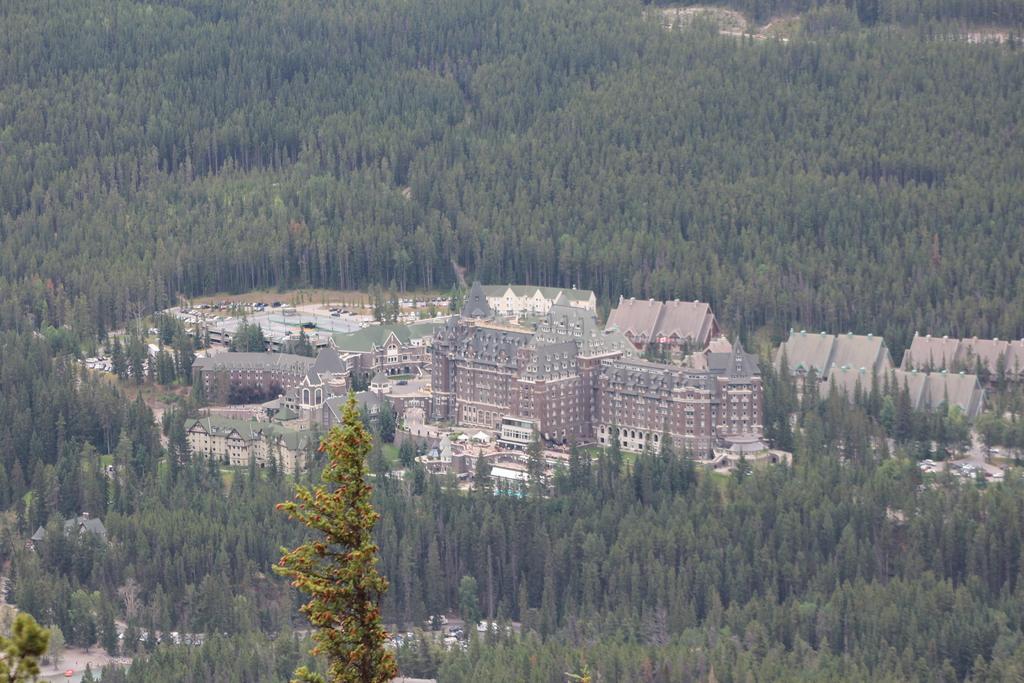How would you summarize this image in a sentence or two? This image consists of many trees and plants. In the middle, there is a fort along with walls and roof. It looks like it is clicked from a plane. 